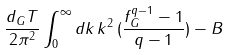Convert formula to latex. <formula><loc_0><loc_0><loc_500><loc_500>\frac { d _ { G } T } { 2 \pi ^ { 2 } } \int _ { 0 } ^ { \infty } d k \, k ^ { 2 } \, ( \frac { f _ { G } ^ { q - 1 } - 1 } { q - 1 } ) - B</formula> 